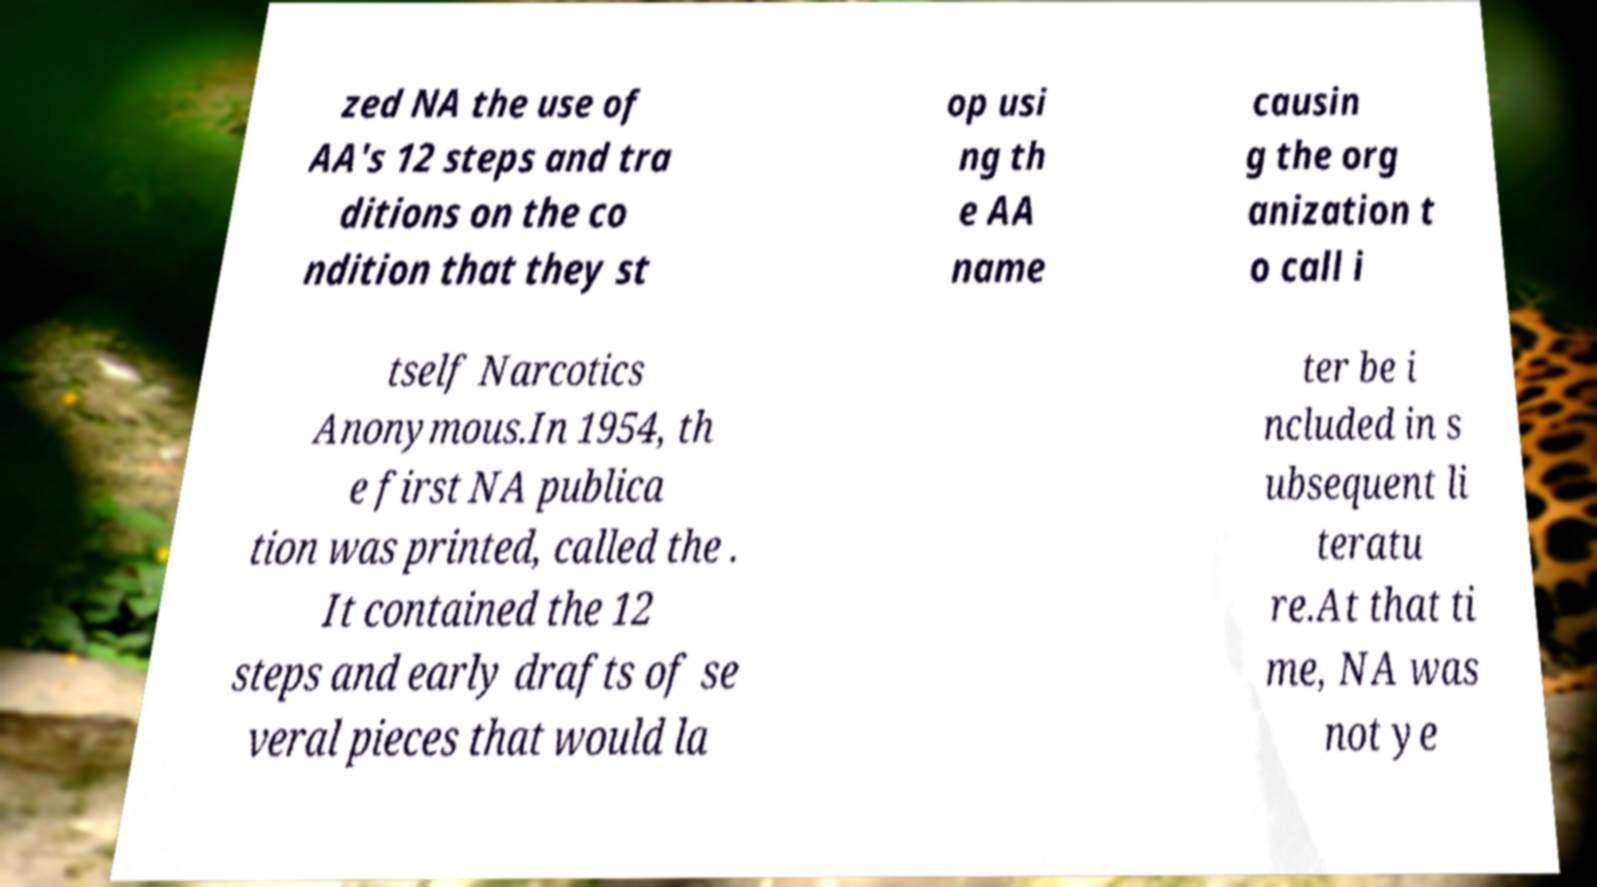Please read and relay the text visible in this image. What does it say? zed NA the use of AA's 12 steps and tra ditions on the co ndition that they st op usi ng th e AA name causin g the org anization t o call i tself Narcotics Anonymous.In 1954, th e first NA publica tion was printed, called the . It contained the 12 steps and early drafts of se veral pieces that would la ter be i ncluded in s ubsequent li teratu re.At that ti me, NA was not ye 